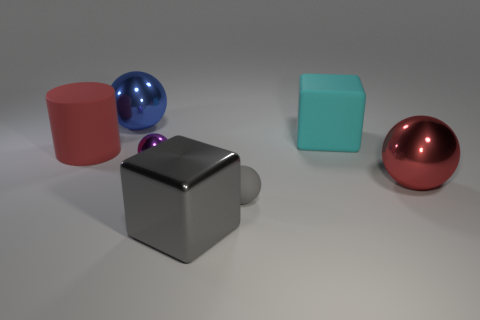There is another thing that is the same shape as the cyan rubber object; what material is it?
Provide a succinct answer. Metal. The large rubber cube is what color?
Offer a terse response. Cyan. There is a big shiny thing that is behind the metal thing that is on the right side of the cyan matte block; what is its color?
Provide a short and direct response. Blue. There is a big rubber cylinder; does it have the same color as the metallic ball that is right of the cyan matte thing?
Provide a succinct answer. Yes. There is a large rubber object that is to the right of the big ball that is behind the red cylinder; what number of gray metal blocks are behind it?
Keep it short and to the point. 0. There is a rubber ball; are there any big shiny things behind it?
Keep it short and to the point. Yes. Are there any other things that are the same color as the cylinder?
Give a very brief answer. Yes. How many cylinders are either blue metallic objects or big red things?
Offer a very short reply. 1. How many large red objects are behind the big red sphere and in front of the large red matte thing?
Provide a succinct answer. 0. Is the number of big gray objects that are behind the large cyan object the same as the number of red metal objects that are to the right of the purple thing?
Your response must be concise. No. 